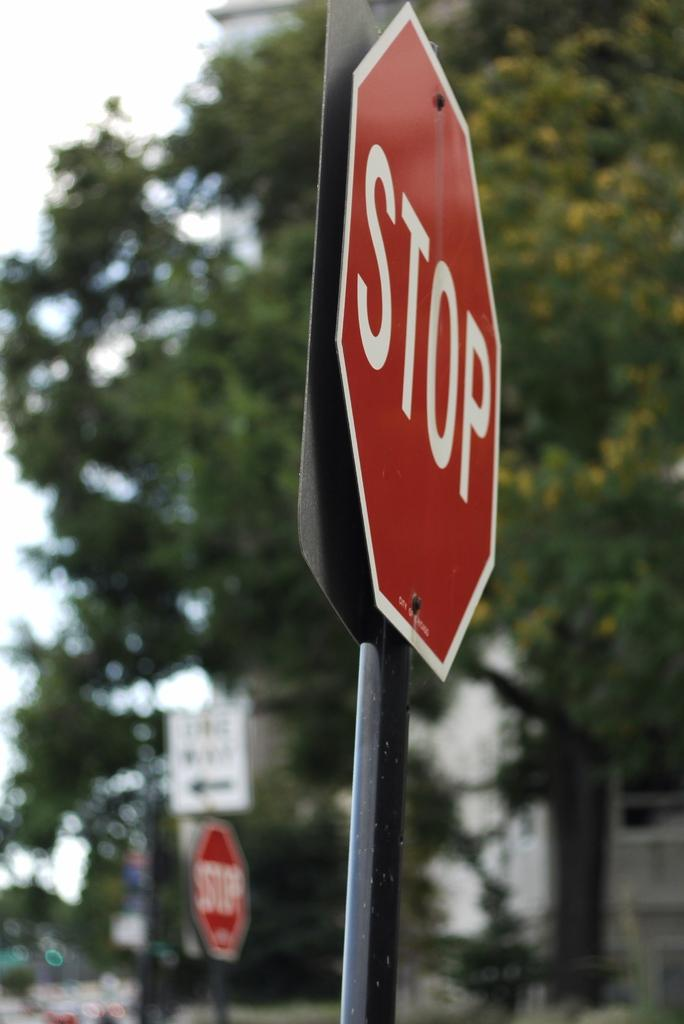<image>
Describe the image concisely. A stop sign on both sides of a one way street. 